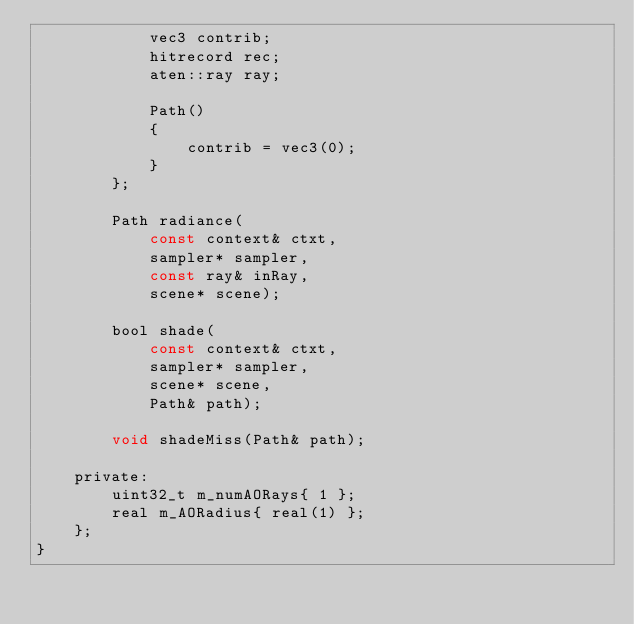<code> <loc_0><loc_0><loc_500><loc_500><_C_>            vec3 contrib;
            hitrecord rec;
            aten::ray ray;

            Path()
            {
                contrib = vec3(0);
            }
        };

        Path radiance(
            const context& ctxt,
            sampler* sampler,
            const ray& inRay,
            scene* scene);

        bool shade(
            const context& ctxt,
            sampler* sampler,
            scene* scene,
            Path& path);

        void shadeMiss(Path& path);

    private:
        uint32_t m_numAORays{ 1 };
        real m_AORadius{ real(1) };
    };
}
</code> 